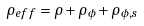Convert formula to latex. <formula><loc_0><loc_0><loc_500><loc_500>\rho _ { e f f } = \rho + \rho _ { \phi } + \rho _ { \phi , s }</formula> 